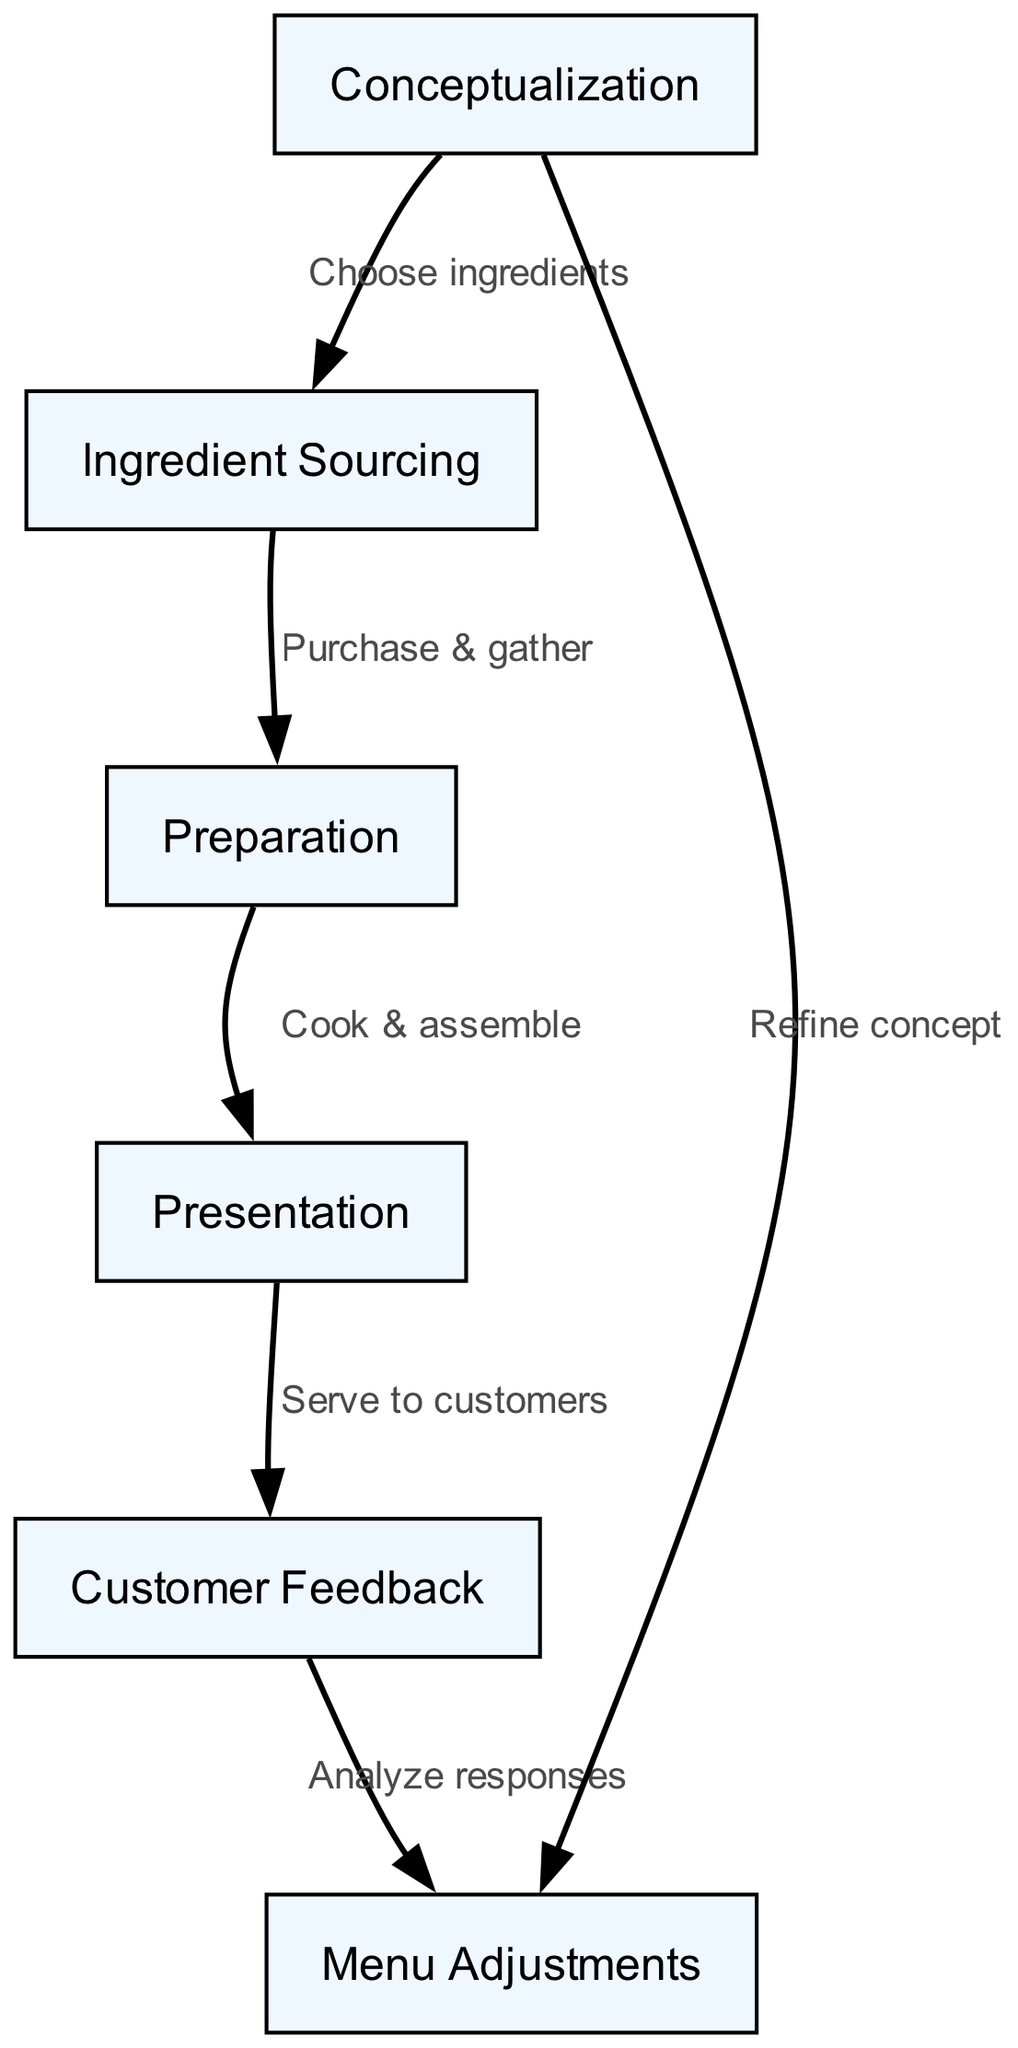What is the total number of nodes in the diagram? The diagram displays a list of distinct nodes representing different stages. By counting these nodes, we find a total of six: conceptualization, ingredient sourcing, preparation, presentation, customer feedback, and menu adjustments.
Answer: 6 What stage comes directly after preparation? In the flow of the diagram, preparation leads to presentation as indicated by the edge connecting these two nodes.
Answer: Presentation Which node is at the beginning of the lifecycle? The first node depicted at the start of the lifecycle process is conceptualization, as it is the foundational stage from which the entire dessert course lifecycle begins.
Answer: Conceptualization How many edges are present in the diagram? By looking at the connections between the nodes, we can count a total of five edges, which represent the relationships between the different stages.
Answer: 5 What is the relationship between customer feedback and menu adjustments? The edge clearly indicates that customer feedback leads to menu adjustments, meaning that responses from customers are analyzed to make potential changes to the menu items.
Answer: Analyze responses Which two nodes have no direct connections? By examining the diagram, we see that there are no edges directly linking the ingredient sourcing node to customer feedback, indicating that they are separate points in the process.
Answer: Ingredient sourcing and customer feedback What action is taken after serving to customers? Following the presentation stage, the next action is to gather customer feedback, as this is the subsequent step in the lifecycle of the dessert course.
Answer: Serve to customers How does the diagram suggest refining the dessert concept? The diagram illustrates that after analyzing customer feedback, the insights gathered lead back to conceptualization, where the dessert concept can be refined based on the responses received.
Answer: Refine concept What is the last stage in the dessert lifecycle chart? The last node in the lifecycle is menu adjustments, signifying the final step that reflects on changes made based on customer feedback and previous stages.
Answer: Menu Adjustments 